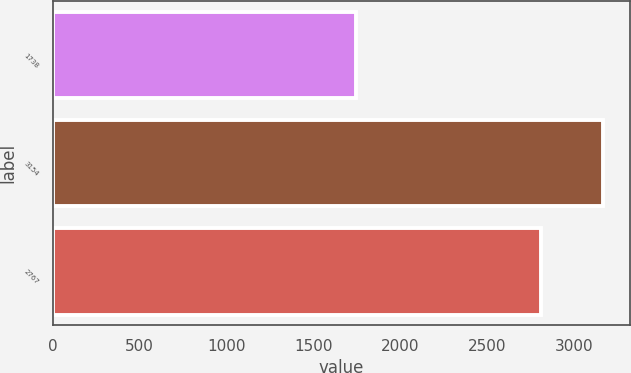Convert chart to OTSL. <chart><loc_0><loc_0><loc_500><loc_500><bar_chart><fcel>1738<fcel>3154<fcel>2767<nl><fcel>1749<fcel>3166<fcel>2813<nl></chart> 